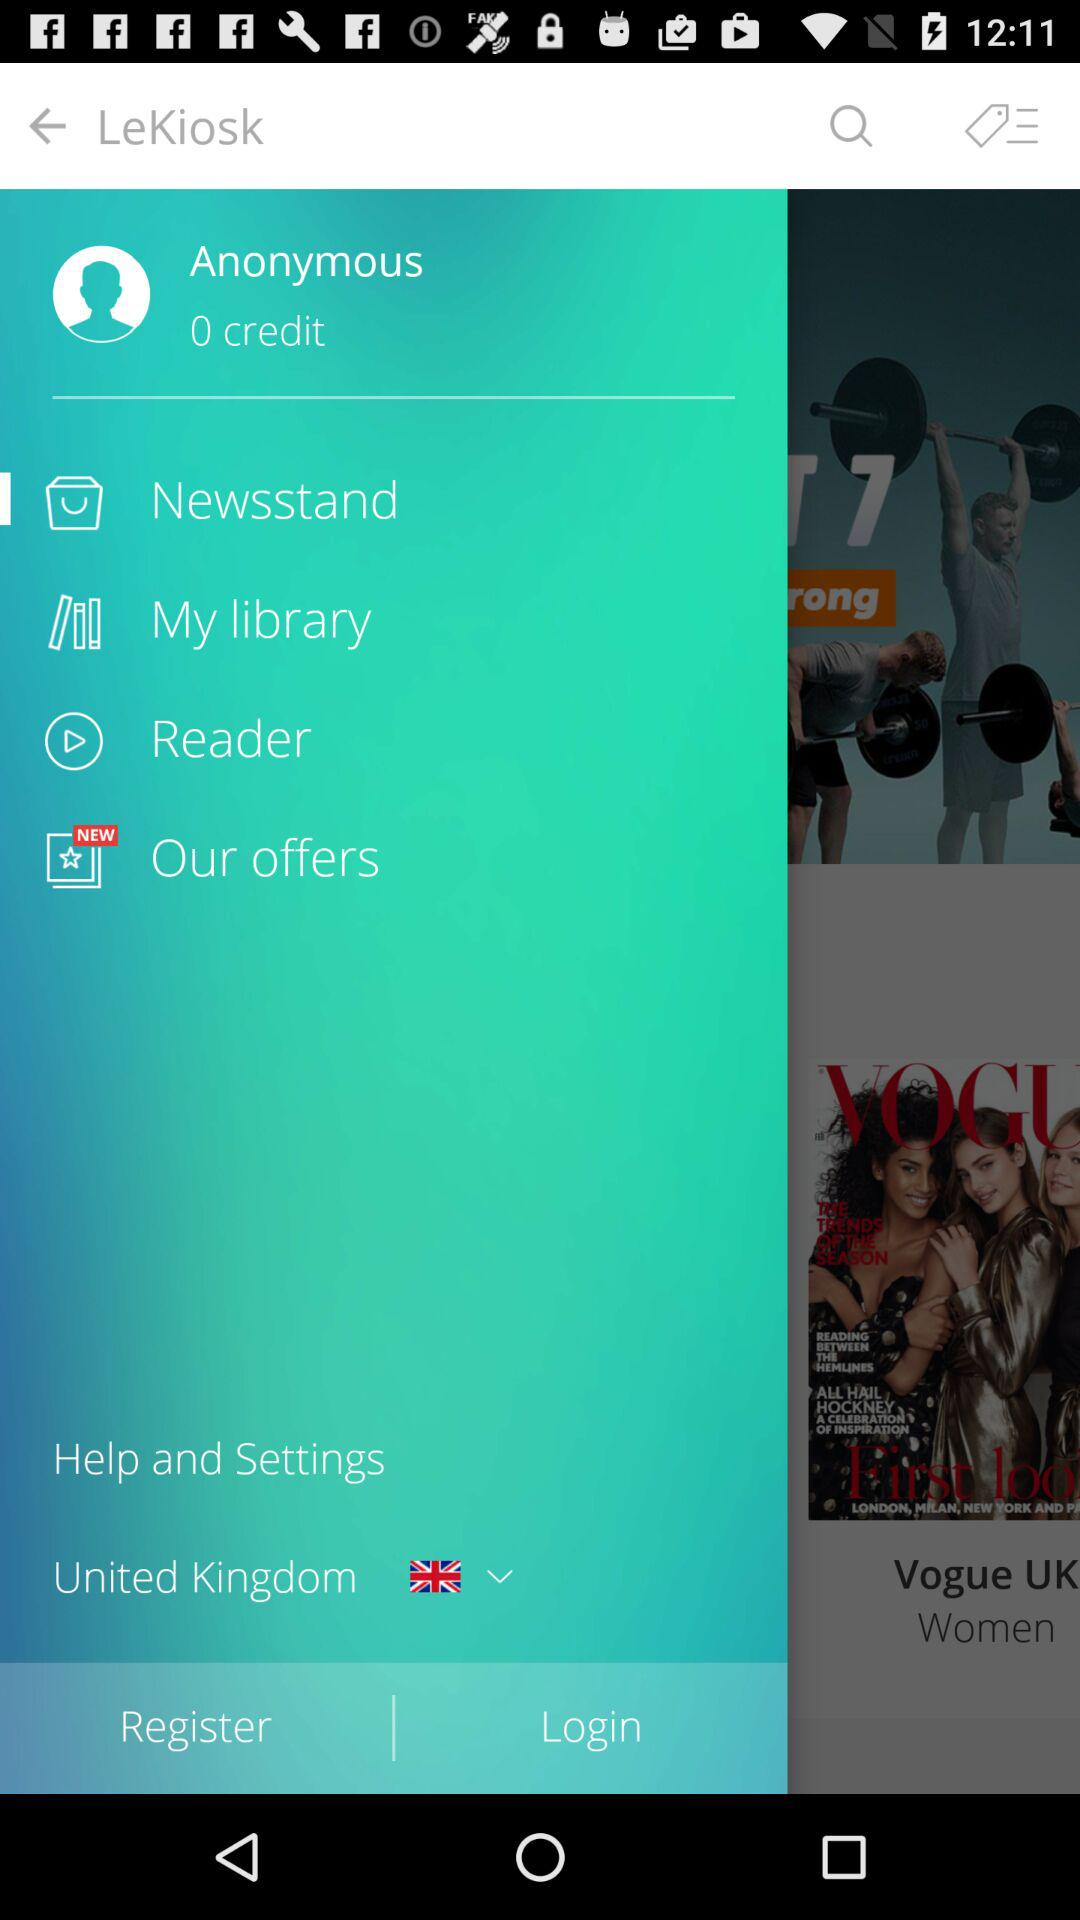Which country has been selected? The selected country is the United Kingdom. 